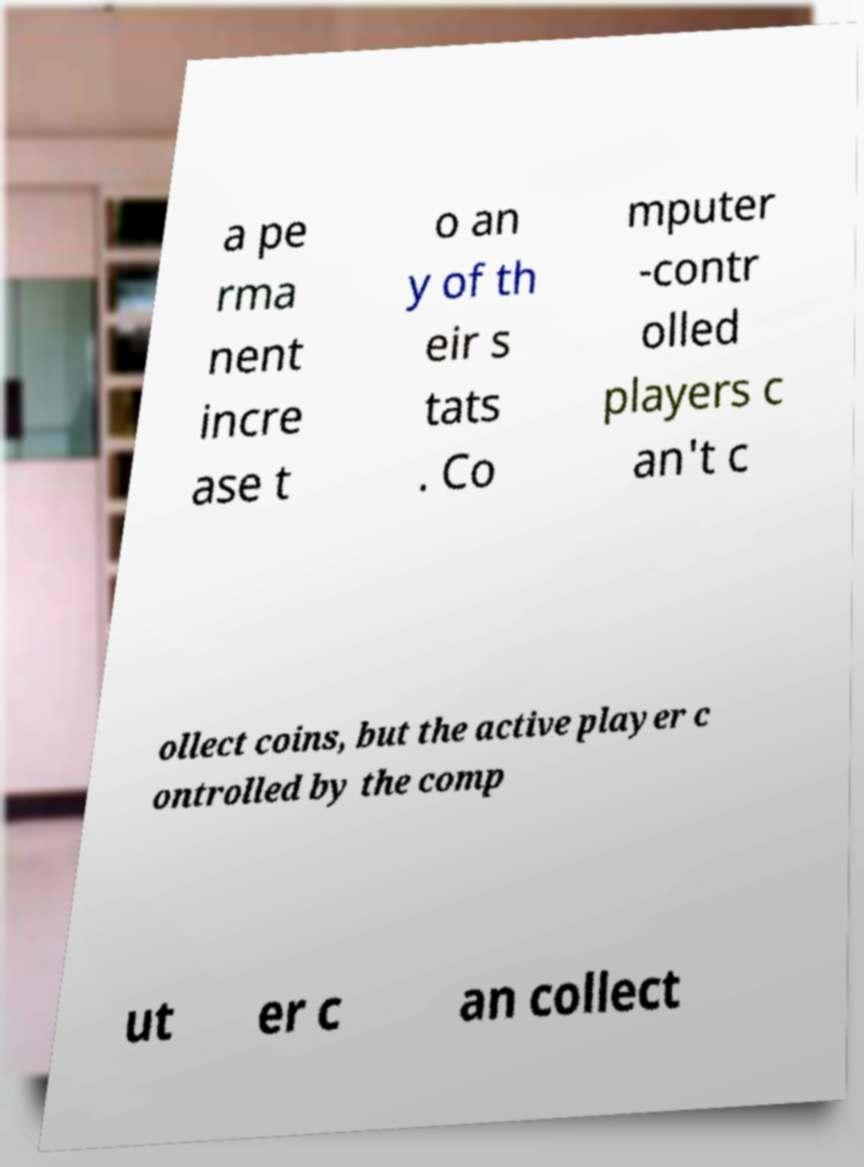Please read and relay the text visible in this image. What does it say? a pe rma nent incre ase t o an y of th eir s tats . Co mputer -contr olled players c an't c ollect coins, but the active player c ontrolled by the comp ut er c an collect 